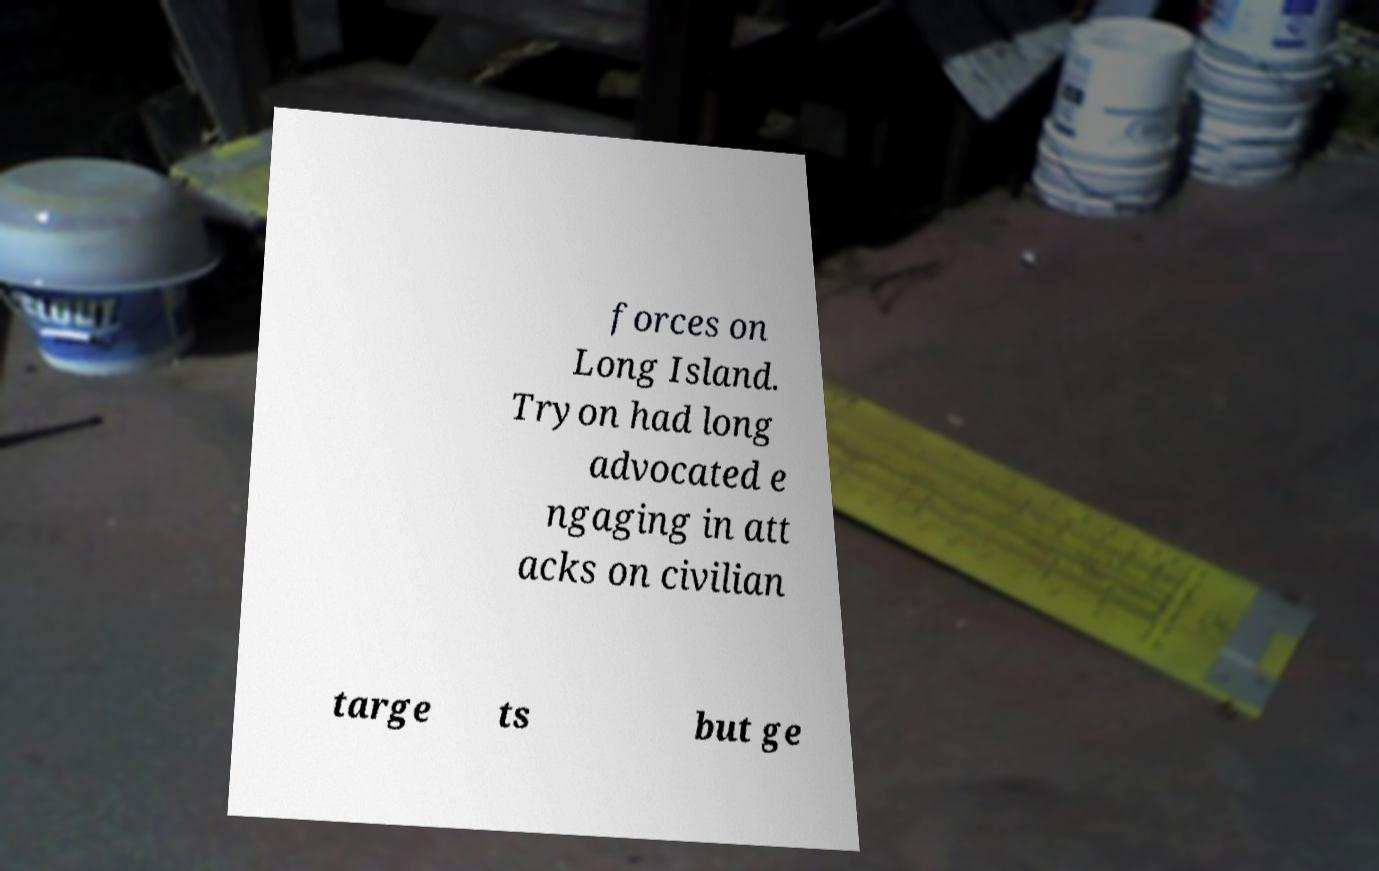Could you extract and type out the text from this image? forces on Long Island. Tryon had long advocated e ngaging in att acks on civilian targe ts but ge 